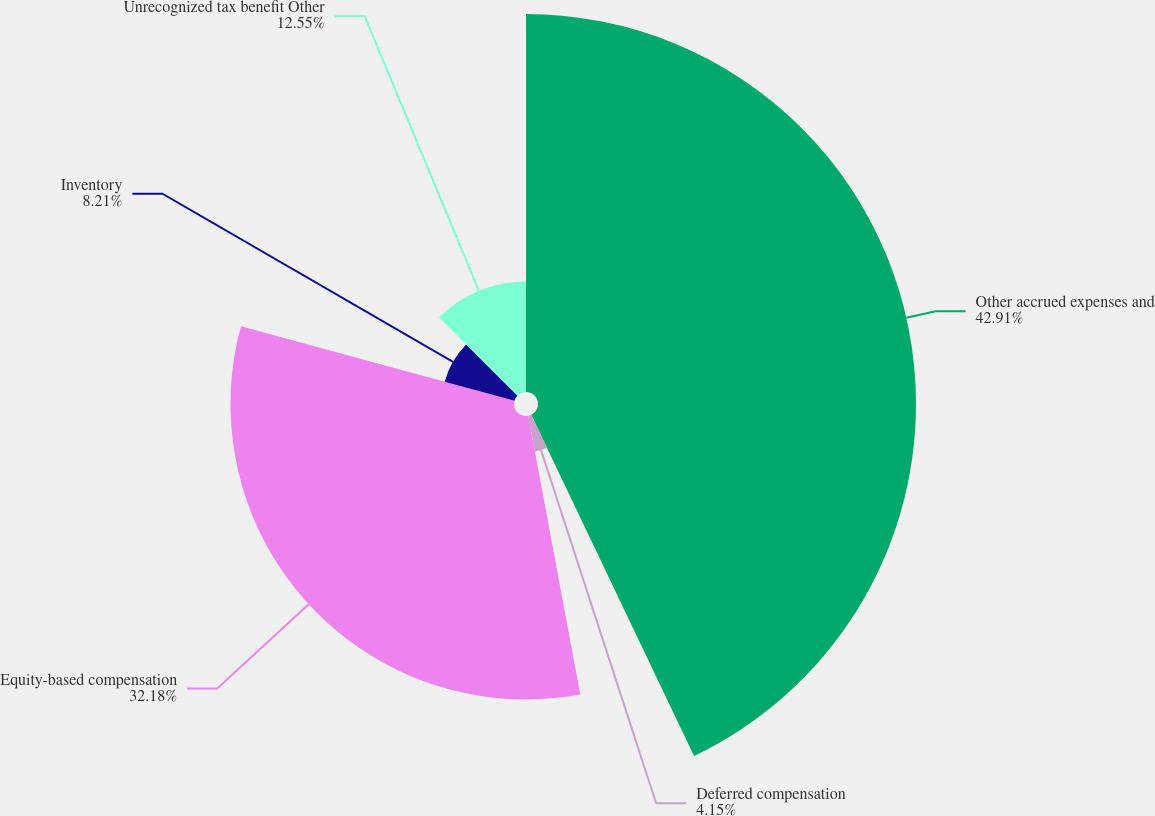Convert chart. <chart><loc_0><loc_0><loc_500><loc_500><pie_chart><fcel>Other accrued expenses and<fcel>Deferred compensation<fcel>Equity-based compensation<fcel>Inventory<fcel>Unrecognized tax benefit Other<nl><fcel>42.91%<fcel>4.15%<fcel>32.18%<fcel>8.21%<fcel>12.55%<nl></chart> 